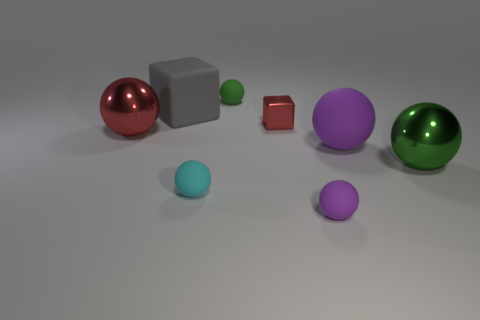Subtract all gray cubes. How many purple balls are left? 2 Subtract all large purple rubber spheres. How many spheres are left? 5 Subtract all cyan spheres. How many spheres are left? 5 Add 1 purple metal balls. How many objects exist? 9 Subtract all cyan spheres. Subtract all brown cubes. How many spheres are left? 5 Subtract all cubes. How many objects are left? 6 Add 7 tiny cyan matte spheres. How many tiny cyan matte spheres are left? 8 Add 8 gray blocks. How many gray blocks exist? 9 Subtract 2 purple spheres. How many objects are left? 6 Subtract all large purple matte balls. Subtract all small red shiny things. How many objects are left? 6 